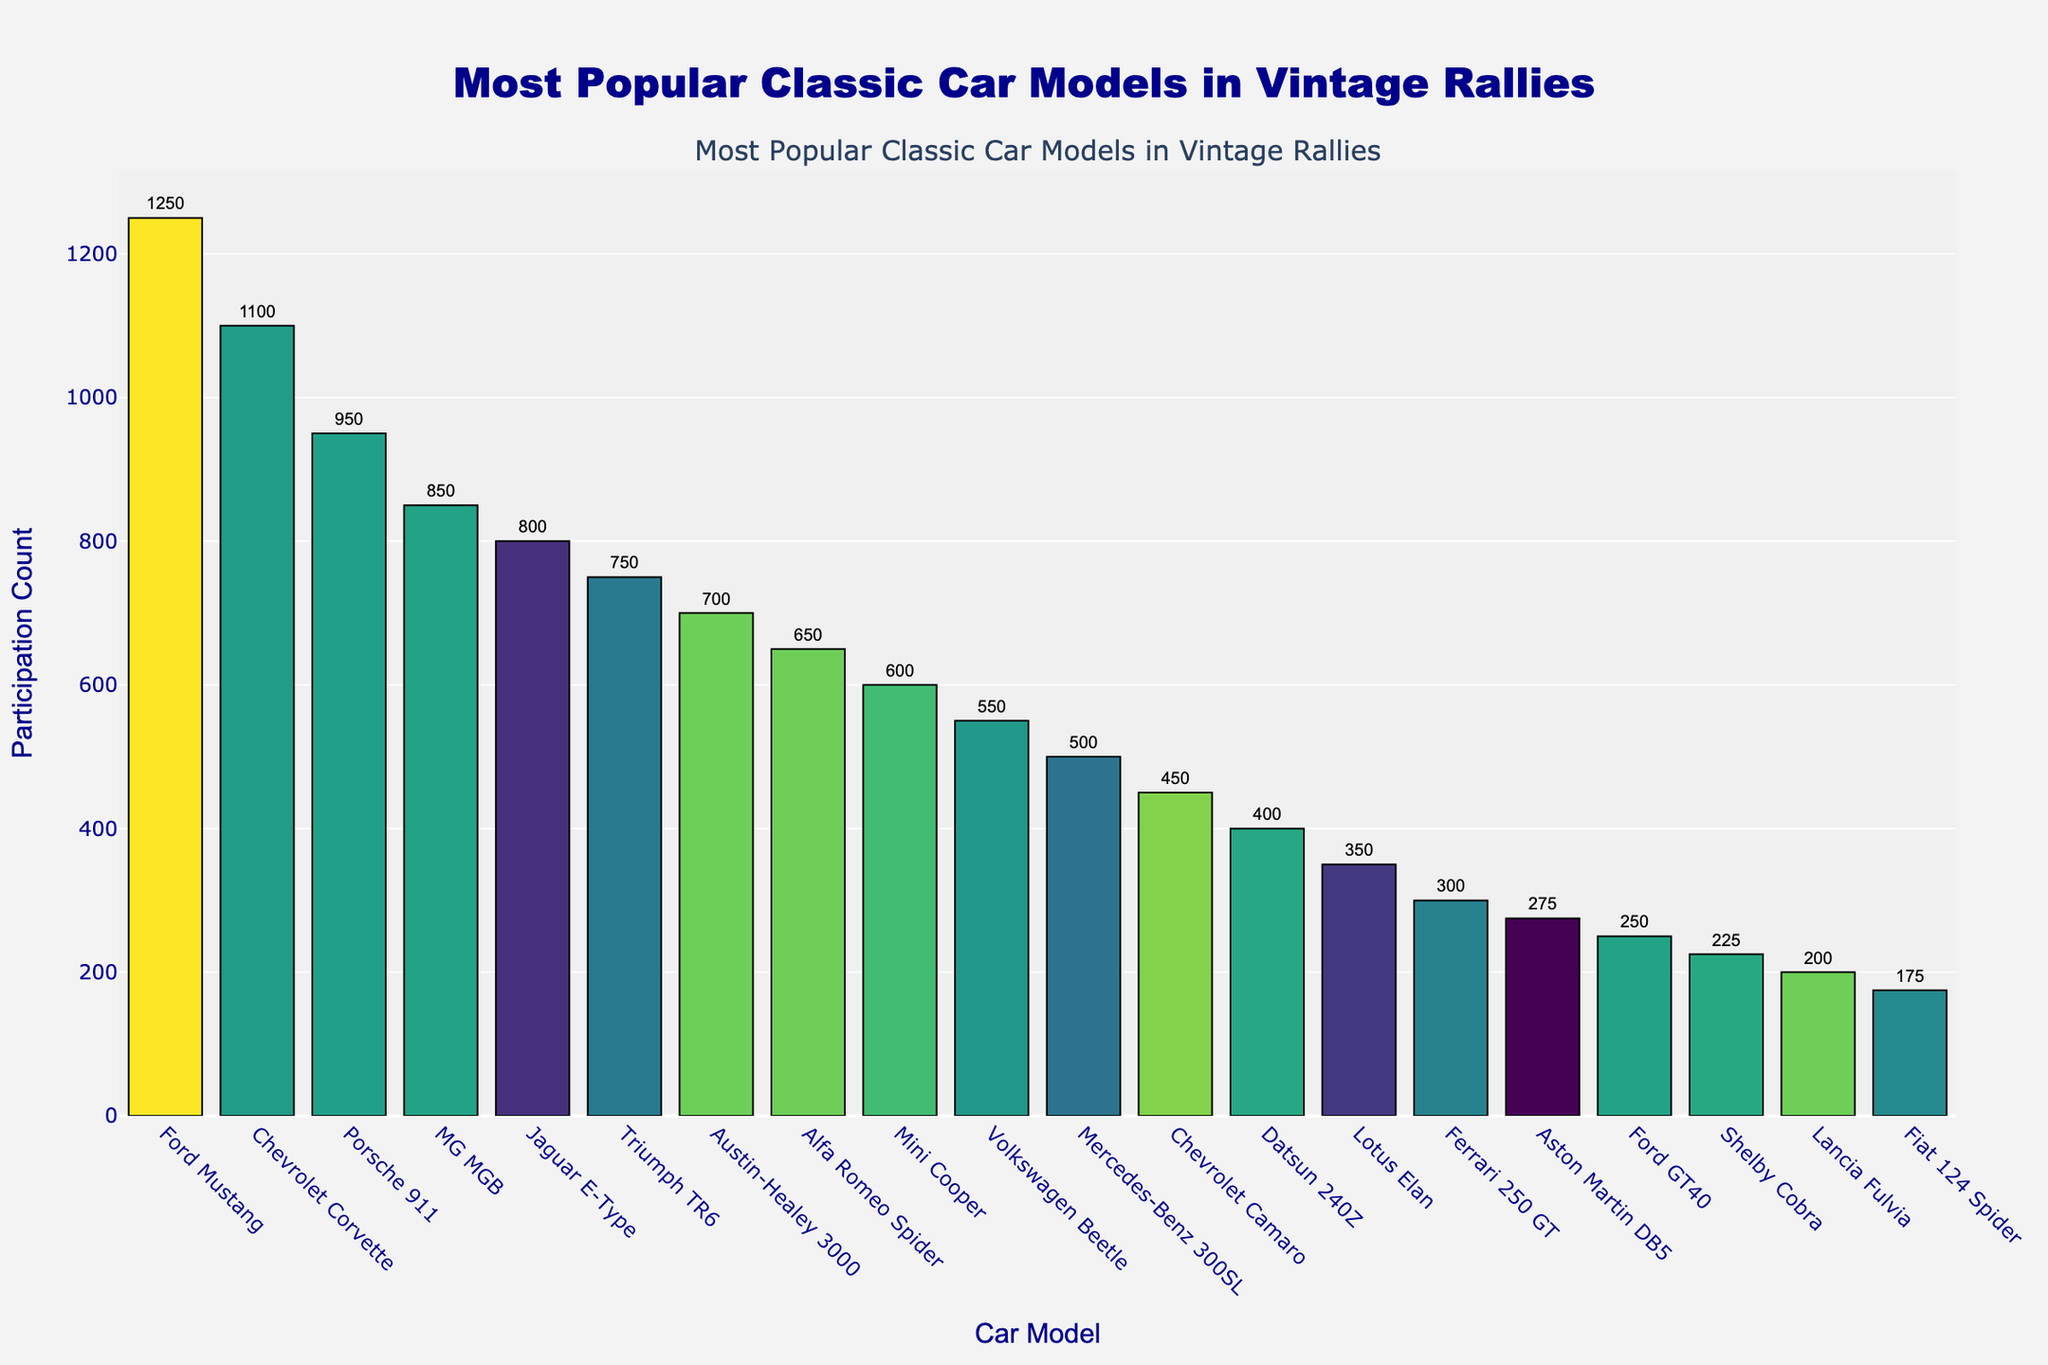Which classic car model has the highest participation count in vintage rallies? The highest bar indicates the car with the most participation. The Ford Mustang's bar is the tallest and is labeled with the highest count of 1,250.
Answer: Ford Mustang How many more times does the Ford Mustang participate compared to the Fiat 124 Spider? Calculate the difference between the participation counts of the Ford Mustang (1,250) and the Fiat 124 Spider (175). The difference is 1,250 - 175 = 1,075.
Answer: 1,075 Which cars have a participation count between 750 and 850? Identify the bars that are within the range of 750 to 850. The MG MGB (850) and Triumph TR6 (750) fall within this range as indicated by the bar lengths and values.
Answer: MG MGB, Triumph TR6 Is the participation count of the Chevrolet Corvette greater than the Jaguar E-Type? Compare the participation counts of the Chevrolet Corvette (1,100) and the Jaguar E-Type (800). 1,100 is greater than 800.
Answer: Yes What is the total participation count for the top three most popular classic car models? Add the participation counts of the top three models: Ford Mustang (1,250), Chevrolet Corvette (1,100), and Porsche 911 (950). The sum is 1,250 + 1,100 + 950 = 3,300.
Answer: 3,300 Which model has the lowest participation count in vintage rallies? The shortest bar in the plot represents the model with the lowest count. The Fiat 124 Spider has the smallest bar with a count of 175.
Answer: Fiat 124 Spider How does the participation count of the Austin-Healey 3000 compare to the Alfa Romeo Spider? Look at the counts of Austin-Healey 3000 (700) and Alfa Romeo Spider (650). The Austin-Healey 3000 has a higher count.
Answer: Austin-Healey 3000 is higher What is the combined participation count of all British car models listed in the data? Add the counts of the British car models: MG MGB (850), Jaguar E-Type (800), Triumph TR6 (750), Austin-Healey 3000 (700), Mini Cooper (600), Lotus Elan (350), and Aston Martin DB5 (275). The sum is 850 + 800 + 750 + 700 + 600 + 350 + 275 = 4,325.
Answer: 4,325 On average, how many times do these classic car models participate in vintage rallies? Calculate the average by summing the counts and dividing by the number of models. The total sum of counts is 11,800 and there are 20 models. The average is 11,800 / 20 = 590.
Answer: 590 Are there more German or Italian car models listed, and by how many? Count the German models: Porsche 911, Volkswagen Beetle, Mercedes-Benz 300SL (3) and the Italian models: Alfa Romeo Spider, Ferrari 250 GT, Lancia Fulvia, Fiat 124 Spider (4). The difference is 4 - 3 = 1.
Answer: Italian by 1 